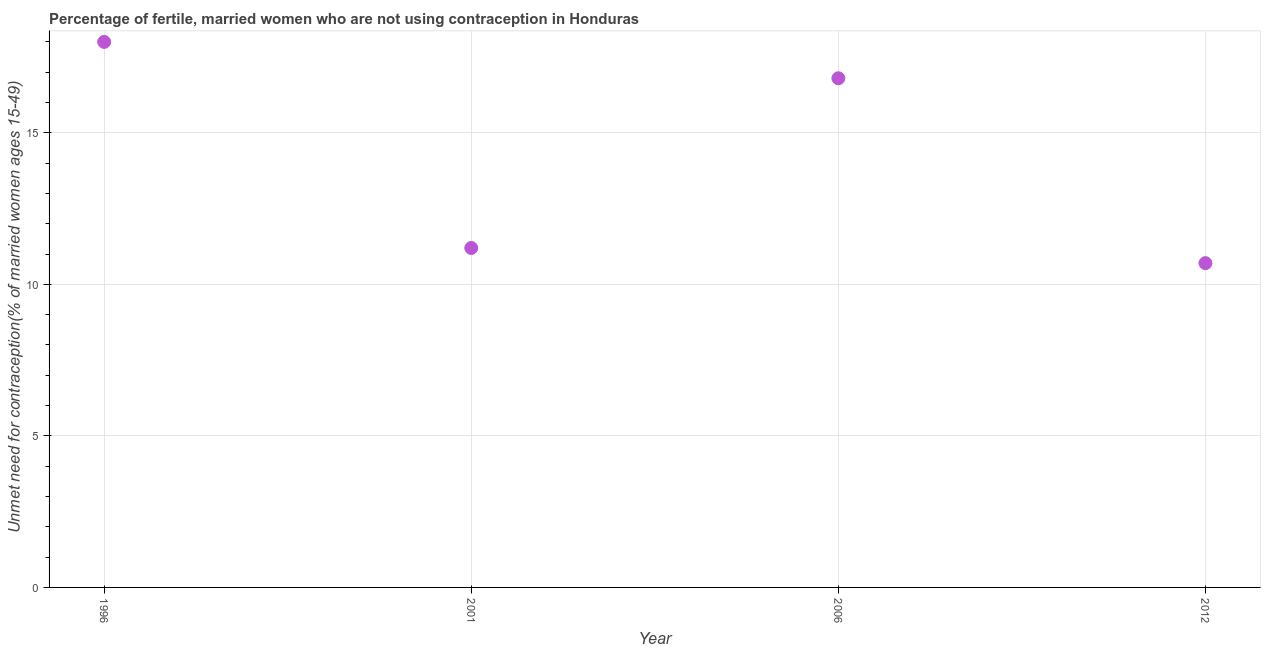Across all years, what is the maximum number of married women who are not using contraception?
Provide a short and direct response. 18. What is the sum of the number of married women who are not using contraception?
Provide a short and direct response. 56.7. What is the difference between the number of married women who are not using contraception in 1996 and 2001?
Keep it short and to the point. 6.8. What is the average number of married women who are not using contraception per year?
Keep it short and to the point. 14.18. In how many years, is the number of married women who are not using contraception greater than 15 %?
Your answer should be compact. 2. Do a majority of the years between 2001 and 2006 (inclusive) have number of married women who are not using contraception greater than 3 %?
Your answer should be very brief. Yes. What is the ratio of the number of married women who are not using contraception in 1996 to that in 2006?
Offer a terse response. 1.07. Is the number of married women who are not using contraception in 2001 less than that in 2006?
Your response must be concise. Yes. Is the difference between the number of married women who are not using contraception in 1996 and 2001 greater than the difference between any two years?
Your answer should be compact. No. What is the difference between the highest and the second highest number of married women who are not using contraception?
Keep it short and to the point. 1.2. What is the difference between the highest and the lowest number of married women who are not using contraception?
Offer a very short reply. 7.3. How many dotlines are there?
Give a very brief answer. 1. How many years are there in the graph?
Offer a very short reply. 4. What is the difference between two consecutive major ticks on the Y-axis?
Your answer should be very brief. 5. Does the graph contain any zero values?
Provide a succinct answer. No. What is the title of the graph?
Offer a very short reply. Percentage of fertile, married women who are not using contraception in Honduras. What is the label or title of the Y-axis?
Your answer should be compact.  Unmet need for contraception(% of married women ages 15-49). What is the  Unmet need for contraception(% of married women ages 15-49) in 2012?
Your answer should be very brief. 10.7. What is the difference between the  Unmet need for contraception(% of married women ages 15-49) in 2006 and 2012?
Provide a succinct answer. 6.1. What is the ratio of the  Unmet need for contraception(% of married women ages 15-49) in 1996 to that in 2001?
Your response must be concise. 1.61. What is the ratio of the  Unmet need for contraception(% of married women ages 15-49) in 1996 to that in 2006?
Provide a short and direct response. 1.07. What is the ratio of the  Unmet need for contraception(% of married women ages 15-49) in 1996 to that in 2012?
Offer a very short reply. 1.68. What is the ratio of the  Unmet need for contraception(% of married women ages 15-49) in 2001 to that in 2006?
Make the answer very short. 0.67. What is the ratio of the  Unmet need for contraception(% of married women ages 15-49) in 2001 to that in 2012?
Give a very brief answer. 1.05. What is the ratio of the  Unmet need for contraception(% of married women ages 15-49) in 2006 to that in 2012?
Provide a short and direct response. 1.57. 